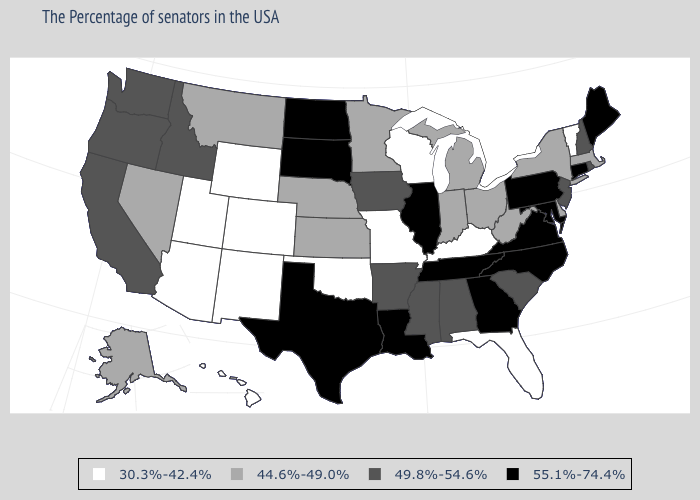Among the states that border Washington , which have the lowest value?
Answer briefly. Idaho, Oregon. What is the value of Tennessee?
Give a very brief answer. 55.1%-74.4%. Which states have the lowest value in the South?
Be succinct. Florida, Kentucky, Oklahoma. What is the value of Iowa?
Write a very short answer. 49.8%-54.6%. What is the lowest value in states that border Arizona?
Write a very short answer. 30.3%-42.4%. Does Kansas have the highest value in the MidWest?
Keep it brief. No. Among the states that border Iowa , does South Dakota have the highest value?
Be succinct. Yes. Name the states that have a value in the range 49.8%-54.6%?
Quick response, please. Rhode Island, New Hampshire, New Jersey, South Carolina, Alabama, Mississippi, Arkansas, Iowa, Idaho, California, Washington, Oregon. Does Colorado have a lower value than Vermont?
Give a very brief answer. No. Name the states that have a value in the range 30.3%-42.4%?
Quick response, please. Vermont, Florida, Kentucky, Wisconsin, Missouri, Oklahoma, Wyoming, Colorado, New Mexico, Utah, Arizona, Hawaii. Which states have the lowest value in the USA?
Concise answer only. Vermont, Florida, Kentucky, Wisconsin, Missouri, Oklahoma, Wyoming, Colorado, New Mexico, Utah, Arizona, Hawaii. What is the value of Louisiana?
Give a very brief answer. 55.1%-74.4%. What is the value of Georgia?
Keep it brief. 55.1%-74.4%. Name the states that have a value in the range 49.8%-54.6%?
Short answer required. Rhode Island, New Hampshire, New Jersey, South Carolina, Alabama, Mississippi, Arkansas, Iowa, Idaho, California, Washington, Oregon. What is the lowest value in the MidWest?
Be succinct. 30.3%-42.4%. 